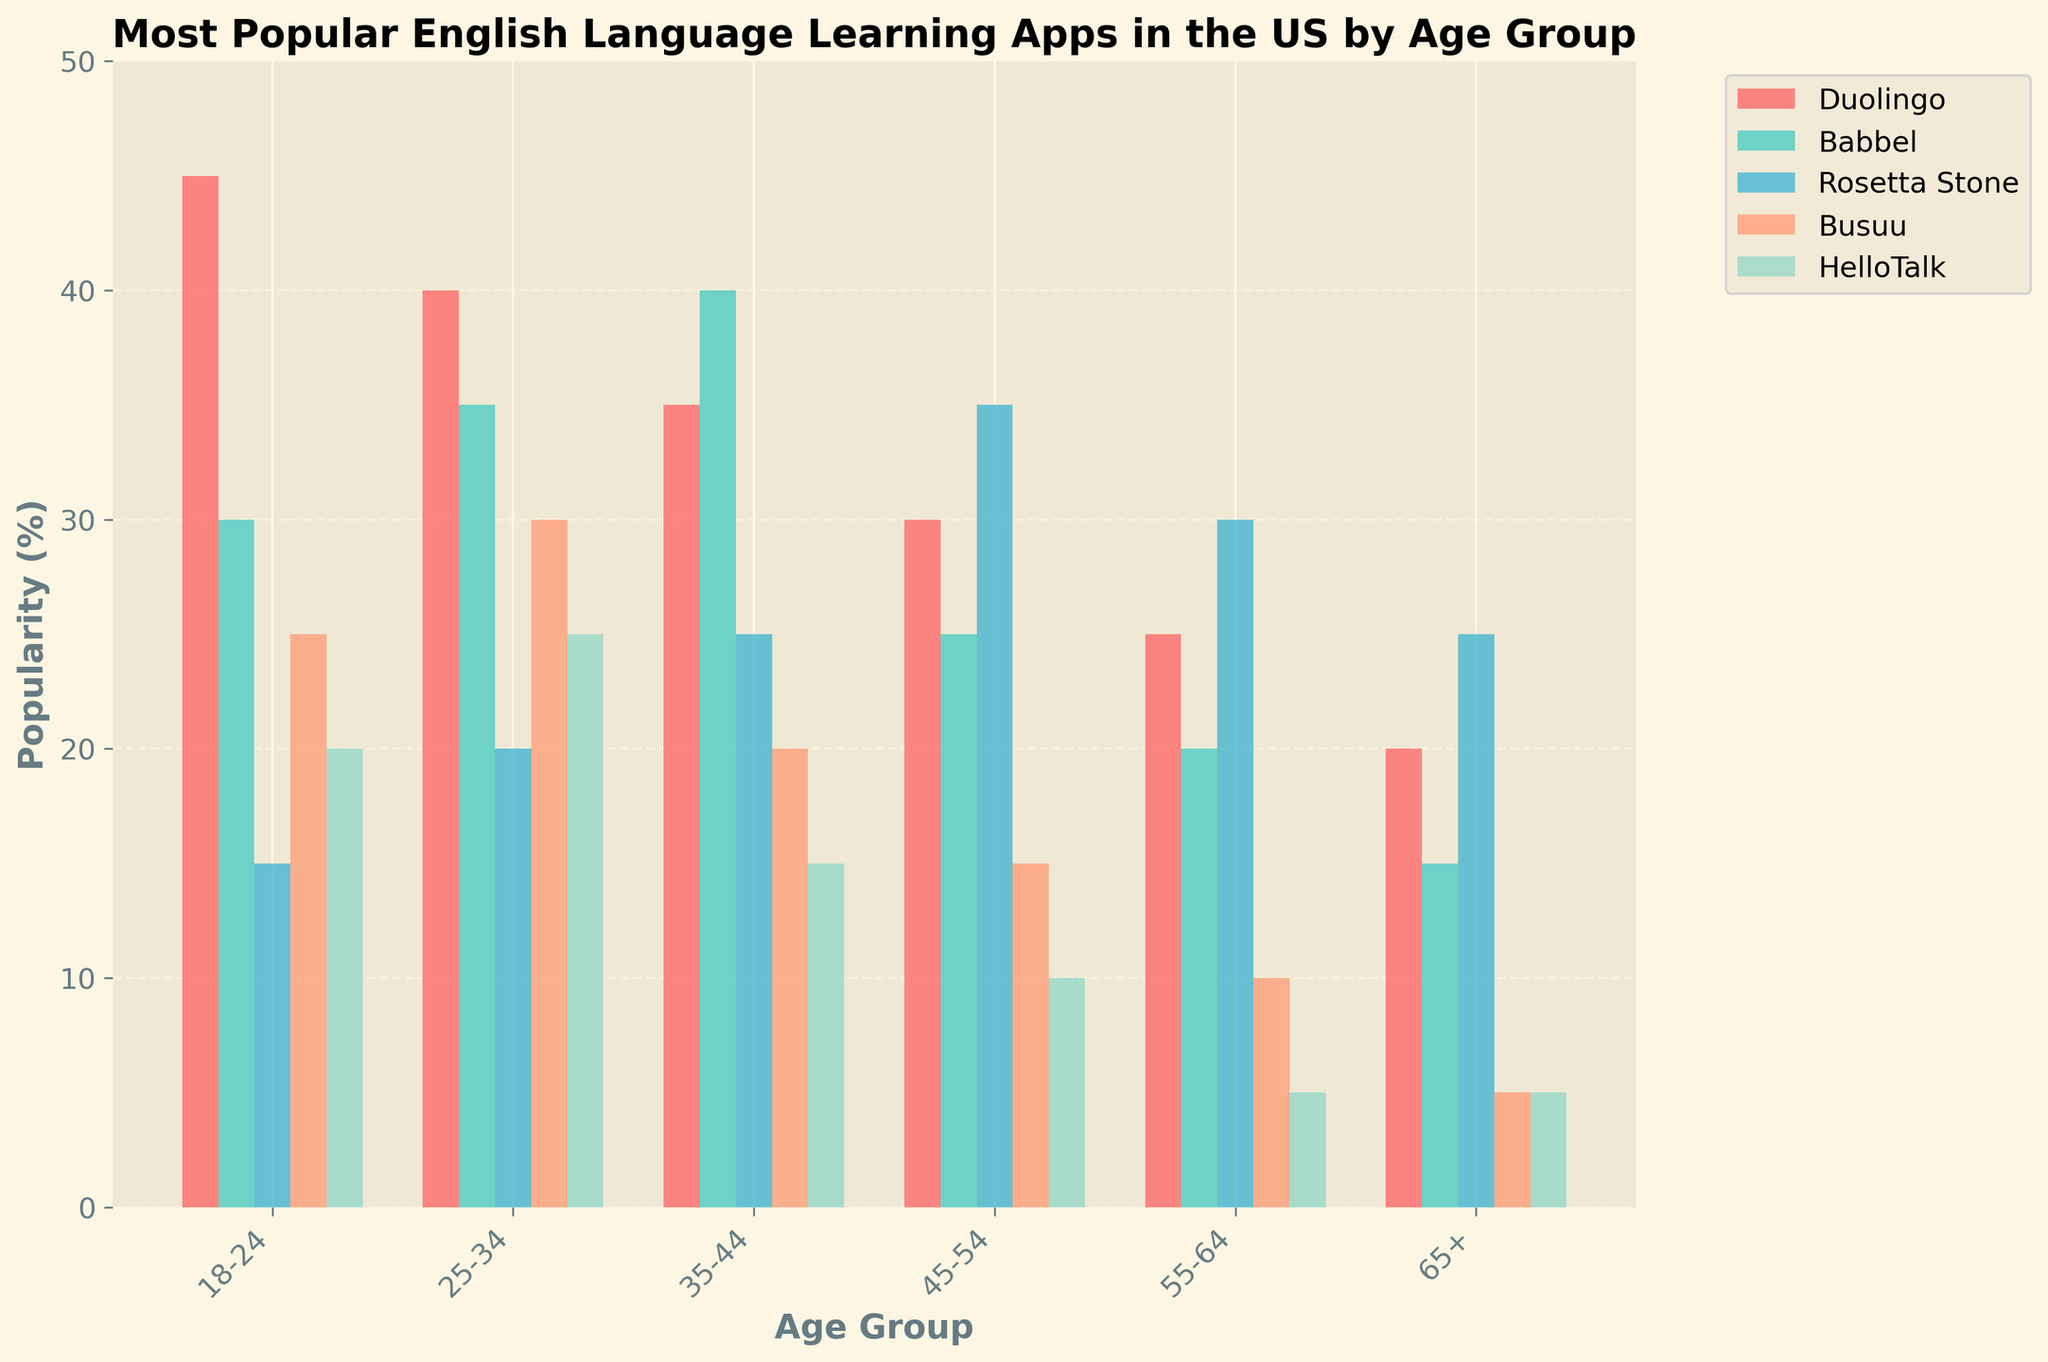What's the most popular English language learning app among the 18-24 age group? Look at the bars corresponding to the 18-24 age group and identify the tallest one.
Answer: Duolingo Which app shows the overall highest popularity percentage across all age groups? Compare the heights of the tallest bars for each app across all age groups.
Answer: Duolingo Among users aged 55-64, which app has the second-highest popularity? Look at the heights of the bars corresponding to the 55-64 age group and identify the second tallest one.
Answer: Rosetta Stone Is Babbel more popular among the 35-44 age group than among the 45-54 age group? Compare the height of Babbel's bars between the 35-44 and 45-54 age groups.
Answer: Yes For which age group is HelloTalk the least popular? Identify the shortest HelloTalk bar and note the corresponding age group.
Answer: 65+ Which age group has the highest combined popularity percentage for all apps? Sum the values of all apps for each age group and compare the results. The highest sum indicates the most popular age group.
Answer: 25-34 What's the popularity difference between Duolingo and Busuu among the 25-34 age group? Subtract the height of Busuu's bar from Duolingo's bar for the 25-34 age group.
Answer: 10 Which two apps have the closest popularity percentages among the 45-54 age group? Compare the bars for the apps in the 45-54 age group and find the two with the closest heights.
Answer: Rosetta Stone and Babbel Does HelloTalk show a higher popularity among the 18-24 age group than the 35-44 age group? Compare the heights of HelloTalk's bars between the 18-24 and 35-44 age groups.
Answer: Yes What is the average popularity of HelloTalk across all age groups? Sum HelloTalk's percentages across all age groups and divide by the number of age groups (6).
Answer: 13.33 